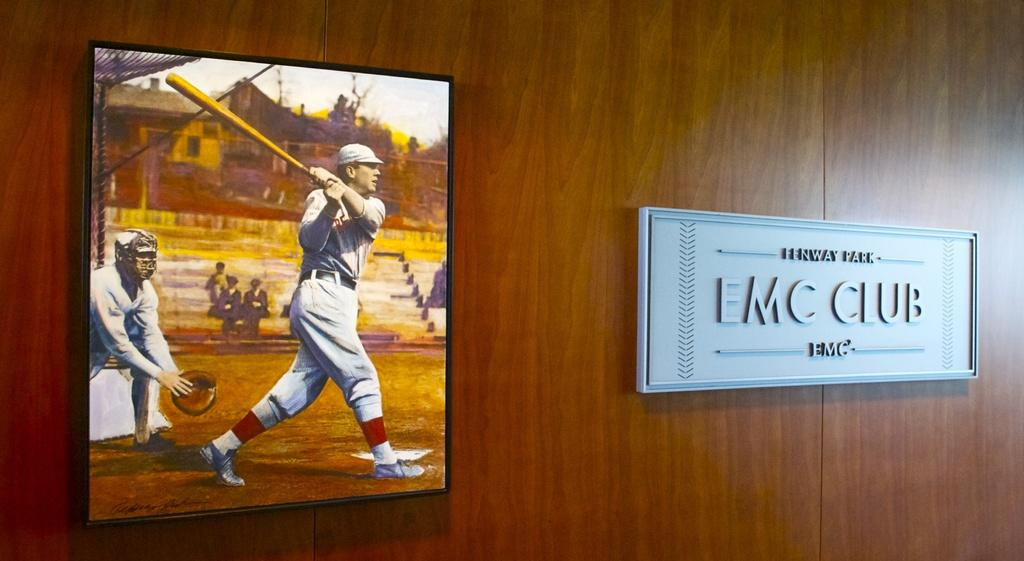<image>
Summarize the visual content of the image. a painting of baseball players near a plaque for the emc club 